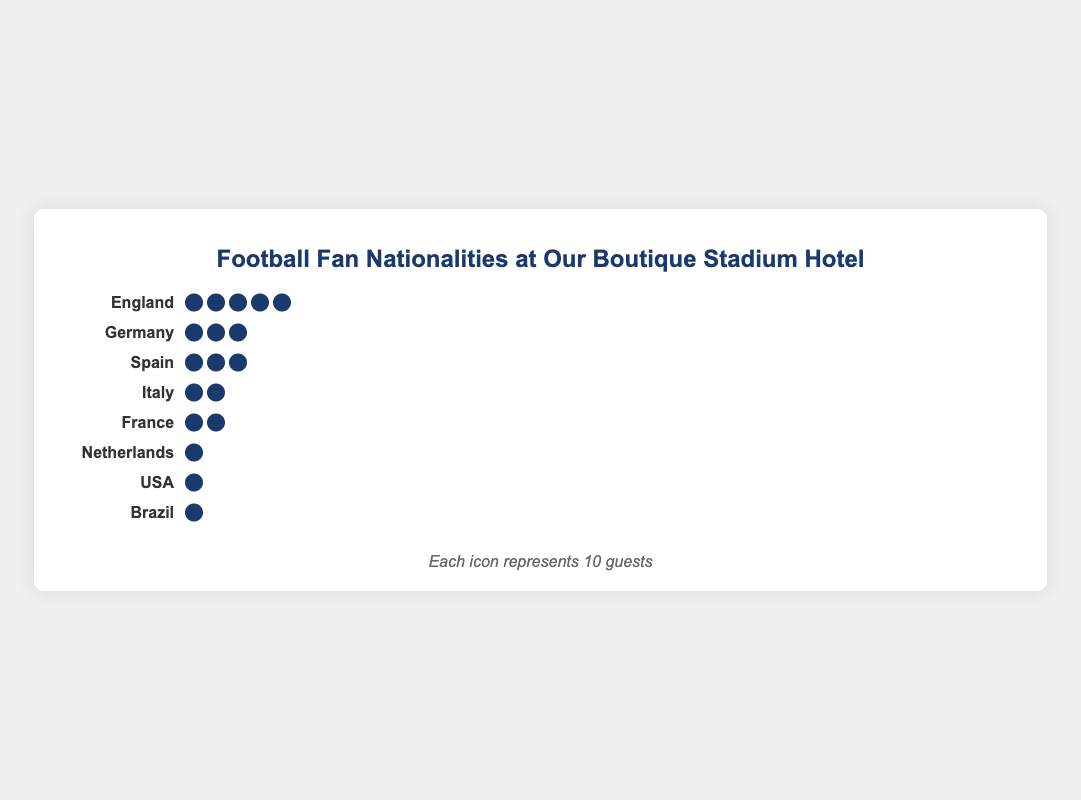How many guests from Brazil stayed at the hotel during major football events? The plot shows an icon for each 10 guests, and Brazil has 7 guests, represented by a single icon.
Answer: 7 Which country had the highest number of guests? The plot indicates the number of guests by the number of icons. England has the highest number of guests with 5 icons (each icon representing 10 guests).
Answer: England What is the total number of guests from Germany and Italy? Germany is shown with 30 guests (3 icons), and Italy is shown with 20 guests (2 icons). The total is 30 + 20 = 50.
Answer: 50 How does the number of French guests compare to the number of Spanish guests? France is represented with 15 guests (1.5 icons) whereas Spain with 25 guests (2.5 icons). Spain has more guests.
Answer: Spain has more guests How many countries have more than 20 guests? England, Germany, and Spain each have more than 20 guests, as indicated by the number of icons.
Answer: 3 countries What is the average number of guests from the listed countries? Total guests = 50 (England) + 30 (Germany) + 25 (Spain) + 20 (Italy) + 15 (France) + 10 (Netherlands) + 8 (USA) + 7 (Brazil) = 165. Average = 165 / 8 = 20.625.
Answer: About 20.6 What is the total number of guests from the countries not based in Europe? USA and Brazil are the non-European countries. USA has 8 guests and Brazil has 7 guests, so 8 + 7 = 15.
Answer: 15 How many countries have exactly 1 icon representing their guests? Each icon represents 10 guests. Both Netherlands (10 guests) and USA (8 guests) are represented with 1 icon each.
Answer: 2 countries 